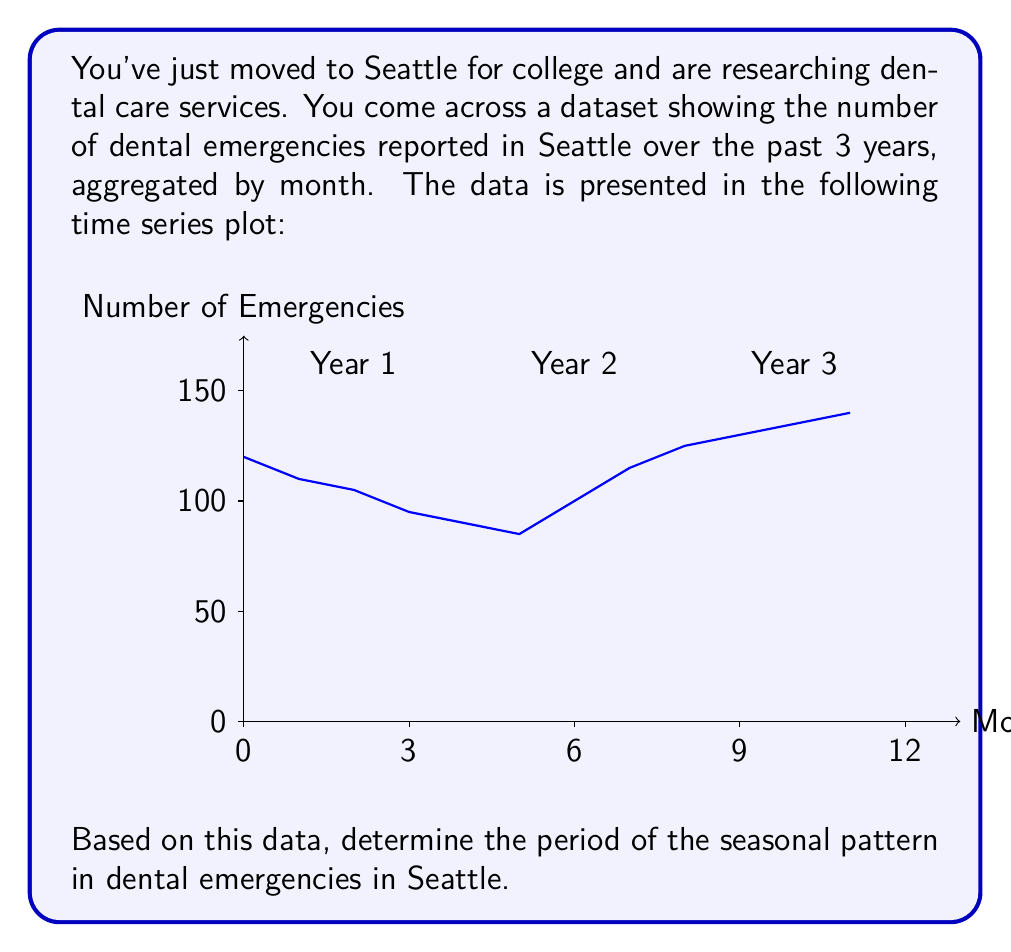Show me your answer to this math problem. To determine the period of the seasonal pattern, we need to analyze the repeating cycle in the time series data. Let's follow these steps:

1) Observe the pattern: The graph shows a repeating pattern that seems to complete one cycle each year.

2) Identify peaks and troughs: We can see that the number of emergencies reaches a peak around the 11th-12th month of each year, and a trough around the 5th-6th month.

3) Calculate the distance between peaks or troughs: 
   - First peak: around month 12
   - Second peak: around month 24
   - Third peak: around month 36

   The distance between each peak is 12 months.

4) Confirm with troughs:
   - First trough: around month 6
   - Second trough: around month 18
   - Third trough: around month 30

   The distance between each trough is also 12 months.

5) Mathematical representation: In time series analysis, we can represent this seasonal component as:

   $$s_t = s_{t+T}$$

   where $s_t$ is the seasonal component at time $t$, and $T$ is the period of the seasonality.

6) In this case, $T = 12$ months, which corresponds to an annual cycle.

Therefore, the seasonal pattern in dental emergencies in Seattle has a period of 12 months, or 1 year.
Answer: 12 months 